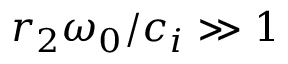<formula> <loc_0><loc_0><loc_500><loc_500>r _ { 2 } \omega _ { 0 } / c _ { i } \gg 1</formula> 